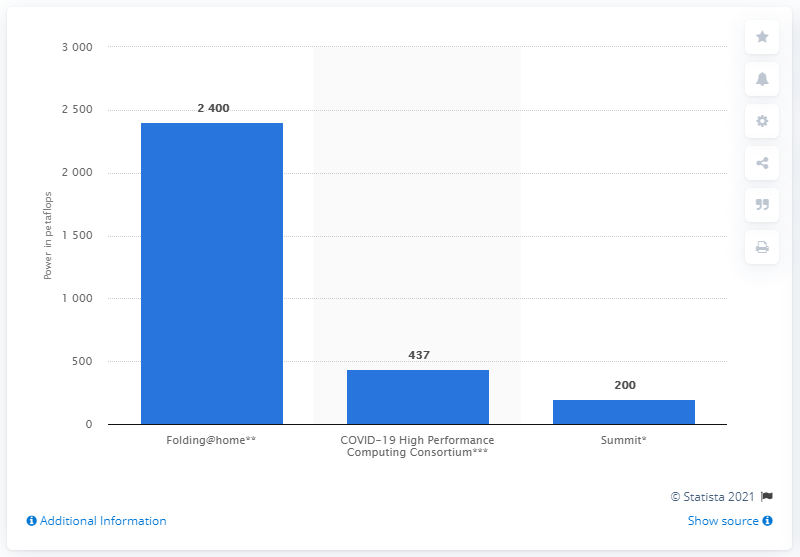Specify some key components in this picture. The COVID-19 High Performance Computing Consortium has access to 437 petaFLOPS of supercomputing power, demonstrating its capabilities in advanced computing. 